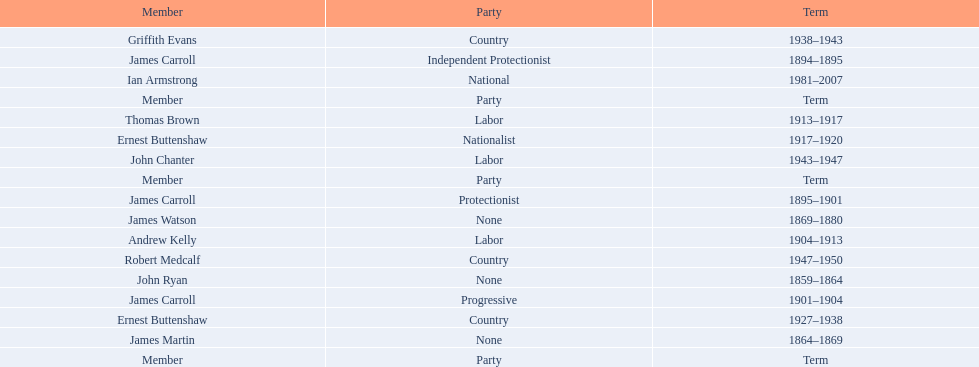How long did ian armstrong serve? 26 years. 